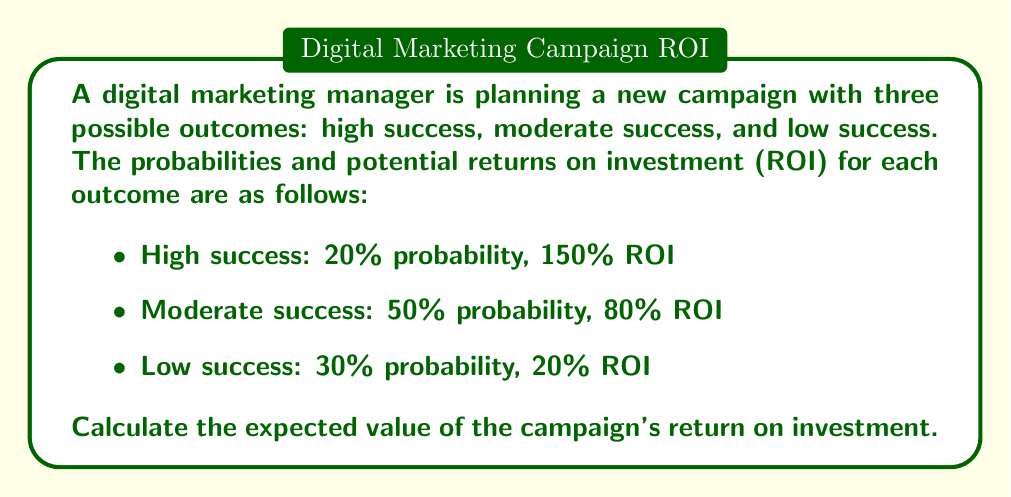Can you solve this math problem? To calculate the expected value of the campaign's return on investment, we need to follow these steps:

1. Identify the random variable: In this case, it's the ROI of the marketing campaign.

2. List all possible outcomes and their probabilities:
   - High success: $p_1 = 0.20$, $ROI_1 = 1.50$
   - Moderate success: $p_2 = 0.50$, $ROI_2 = 0.80$
   - Low success: $p_3 = 0.30$, $ROI_3 = 0.20$

3. Apply the expected value formula:
   $$E(X) = \sum_{i=1}^n p_i \cdot x_i$$
   Where $E(X)$ is the expected value, $p_i$ is the probability of each outcome, and $x_i$ is the value of each outcome.

4. Substitute the values into the formula:
   $$E(ROI) = (0.20 \cdot 1.50) + (0.50 \cdot 0.80) + (0.30 \cdot 0.20)$$

5. Calculate each term:
   $$E(ROI) = 0.30 + 0.40 + 0.06$$

6. Sum up the results:
   $$E(ROI) = 0.76$$

7. Convert to percentage:
   $$E(ROI) = 76\%$$
Answer: 76% 